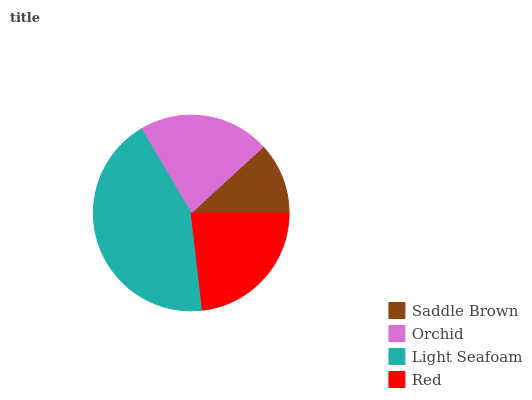Is Saddle Brown the minimum?
Answer yes or no. Yes. Is Light Seafoam the maximum?
Answer yes or no. Yes. Is Orchid the minimum?
Answer yes or no. No. Is Orchid the maximum?
Answer yes or no. No. Is Orchid greater than Saddle Brown?
Answer yes or no. Yes. Is Saddle Brown less than Orchid?
Answer yes or no. Yes. Is Saddle Brown greater than Orchid?
Answer yes or no. No. Is Orchid less than Saddle Brown?
Answer yes or no. No. Is Red the high median?
Answer yes or no. Yes. Is Orchid the low median?
Answer yes or no. Yes. Is Light Seafoam the high median?
Answer yes or no. No. Is Red the low median?
Answer yes or no. No. 